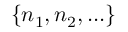<formula> <loc_0><loc_0><loc_500><loc_500>\{ n _ { 1 } , n _ { 2 } , \dots \}</formula> 